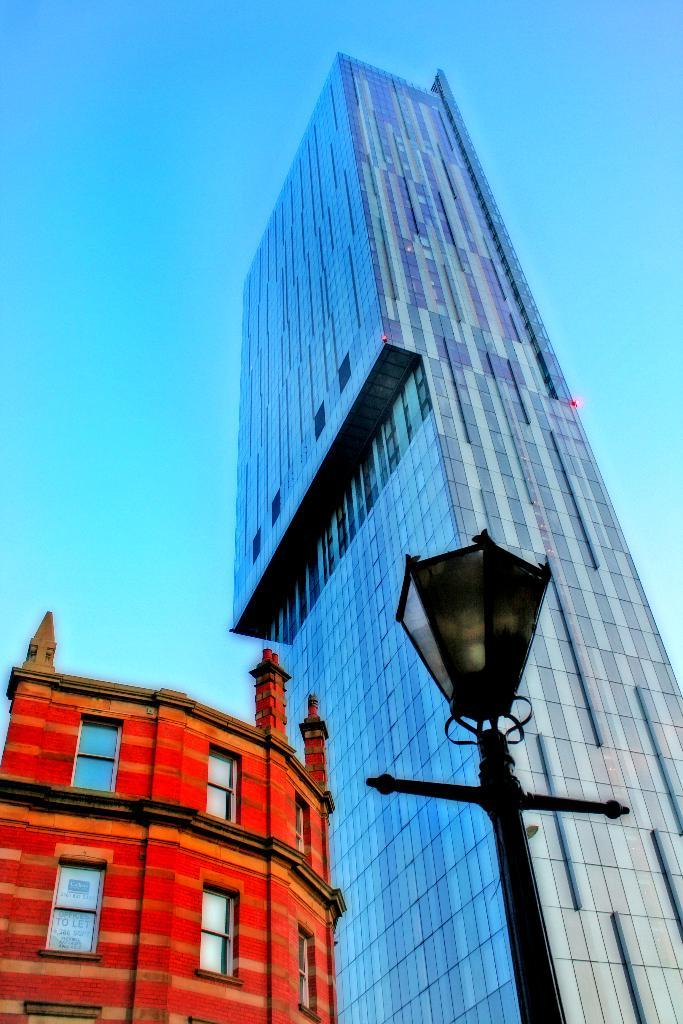How many buildings can be seen in the image? There are two buildings in the image. What is located in the foreground of the image? There is a light on a pole in the foreground of the image. What can be seen in the background of the image? The sky is visible in the background of the image. What holiday is being celebrated in the image? There is no indication of a holiday being celebrated in the image. Which direction is the image facing, north or south? The direction the image is facing cannot be determined from the information provided. 